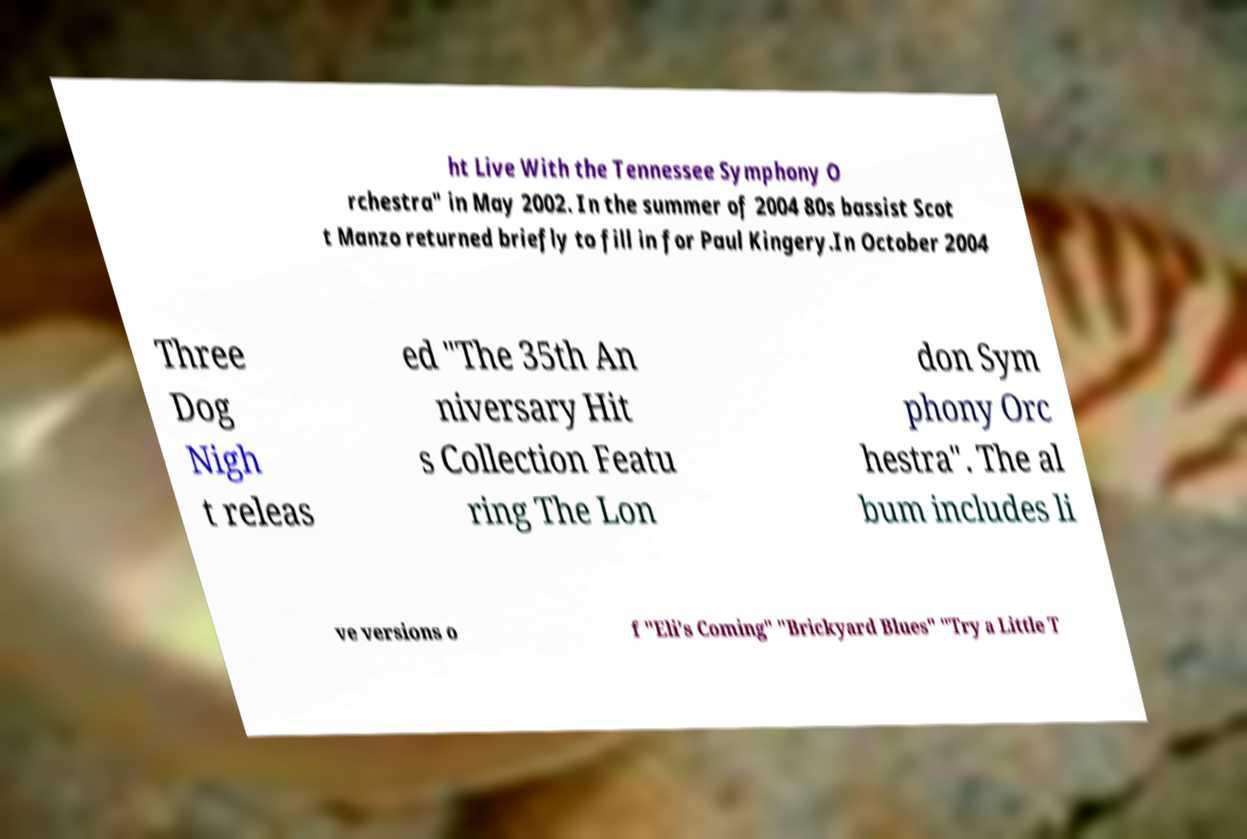Please read and relay the text visible in this image. What does it say? ht Live With the Tennessee Symphony O rchestra" in May 2002. In the summer of 2004 80s bassist Scot t Manzo returned briefly to fill in for Paul Kingery.In October 2004 Three Dog Nigh t releas ed "The 35th An niversary Hit s Collection Featu ring The Lon don Sym phony Orc hestra". The al bum includes li ve versions o f "Eli's Coming" "Brickyard Blues" "Try a Little T 